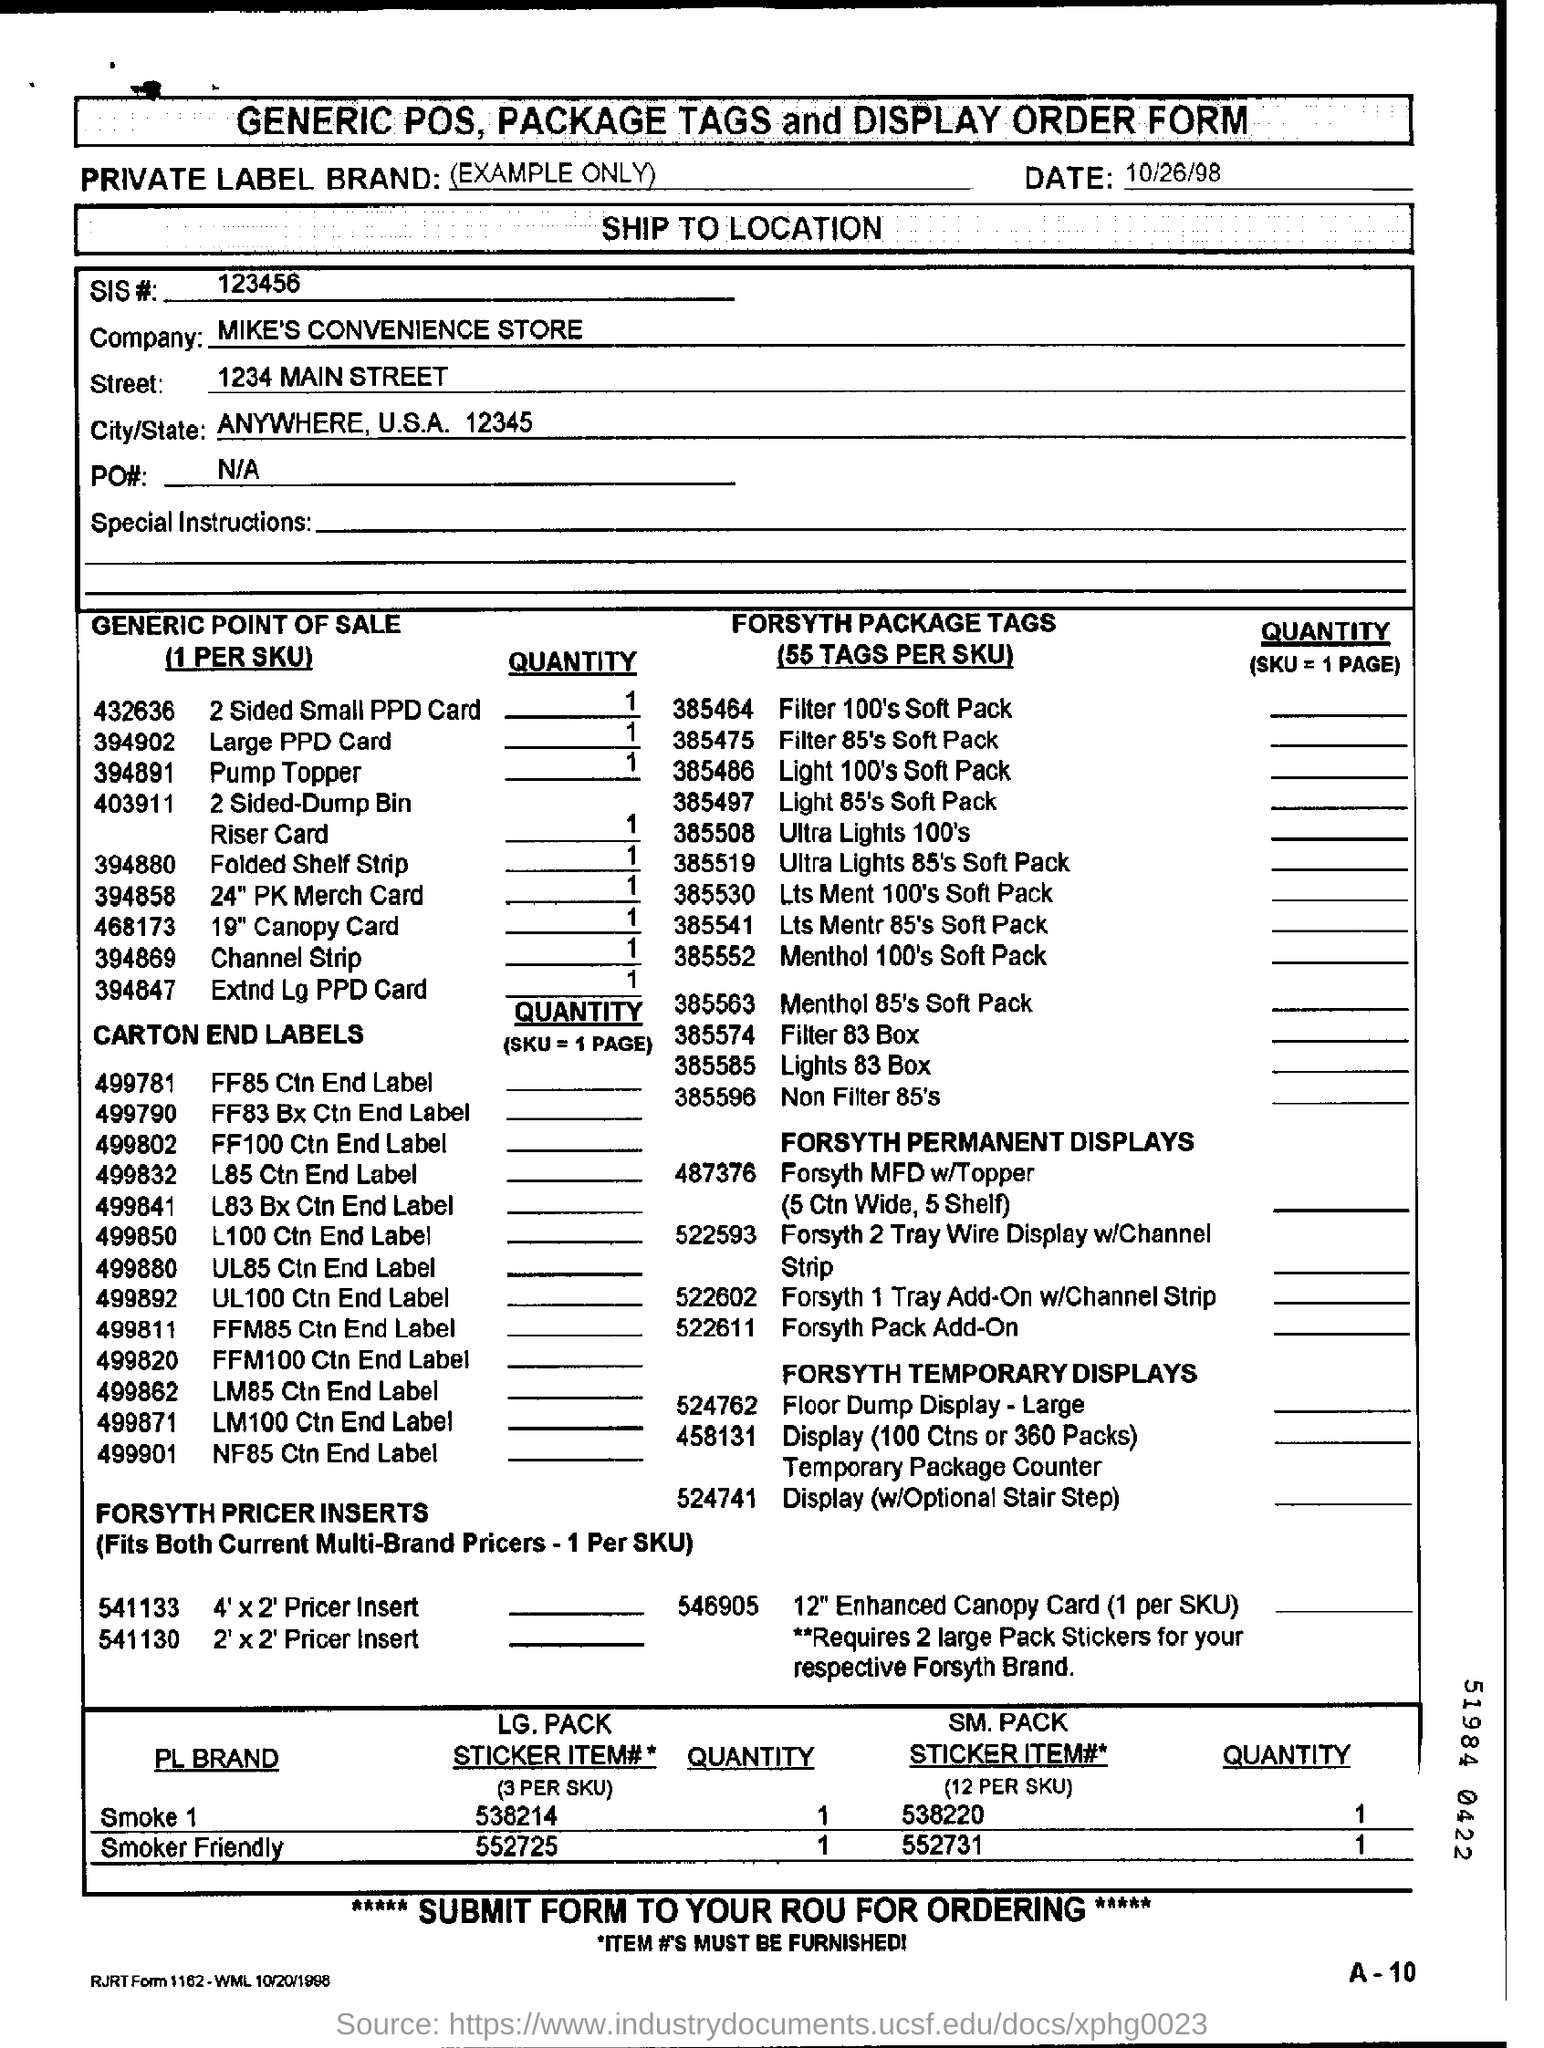What is the SIS #?
Your response must be concise. 123456. What is the company name?
Your response must be concise. MIKE'S CONVENIENCE STORE. What is the date on the form?
Give a very brief answer. 10/26/98. 